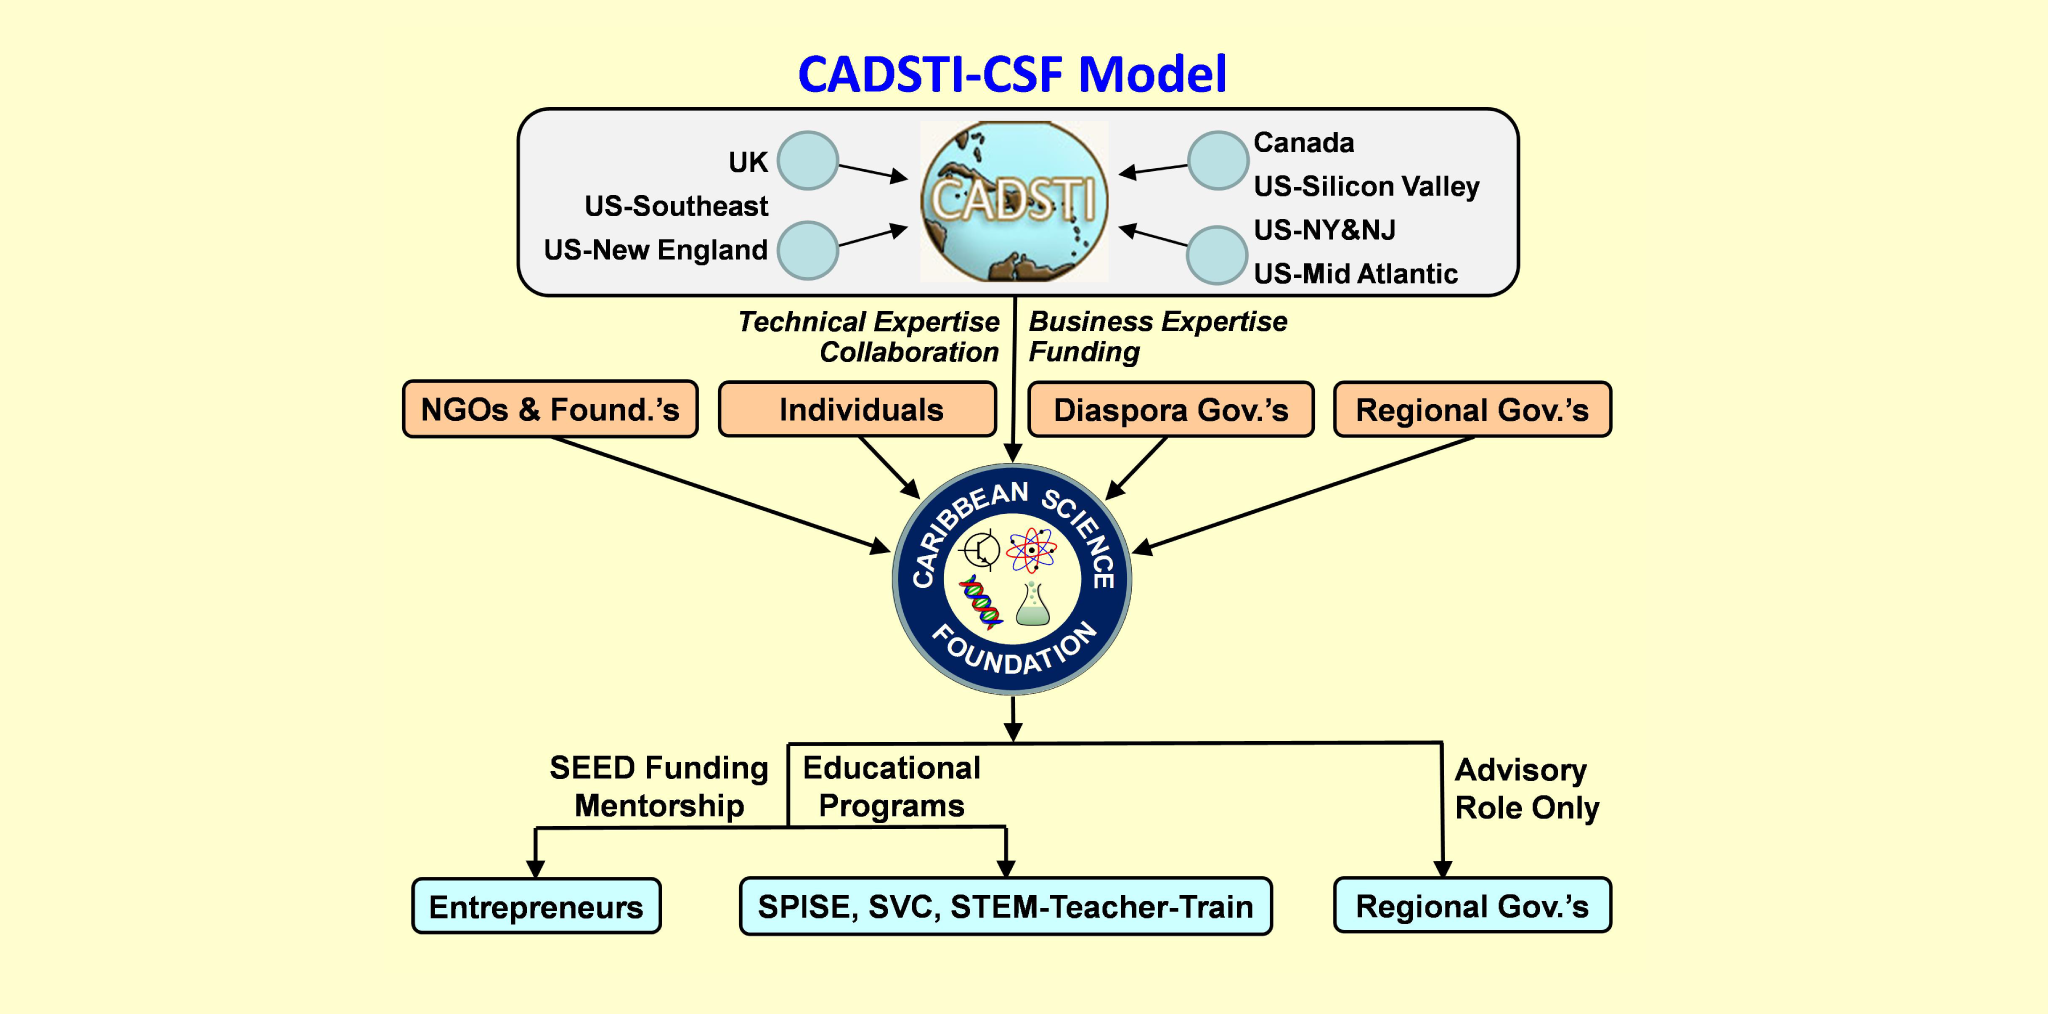Imagine a futuristic scenario where the Caribbean Science Foundation has successfully expanded its reach into space exploration. How might collaborations with international space agencies change their operational activities? In a futuristic scenario where the Caribbean Science Foundation expands into space exploration, collaborations with international space agencies such as NASA or the European Space Agency could dramatically transform its operations. These partnerships could lead to the development of specialized educational programs in astrobiology, aerospace engineering, and planetary science. Additionally, the CSF might receive funding and technical support for setting up regional space research facilities, fostering international internships, and enabling Caribbean students and scientists to participate in global space missions. Ultimately, such collaborations could place the Caribbean at the forefront of space research and innovation, inspiring future generations to explore beyond our planet. 